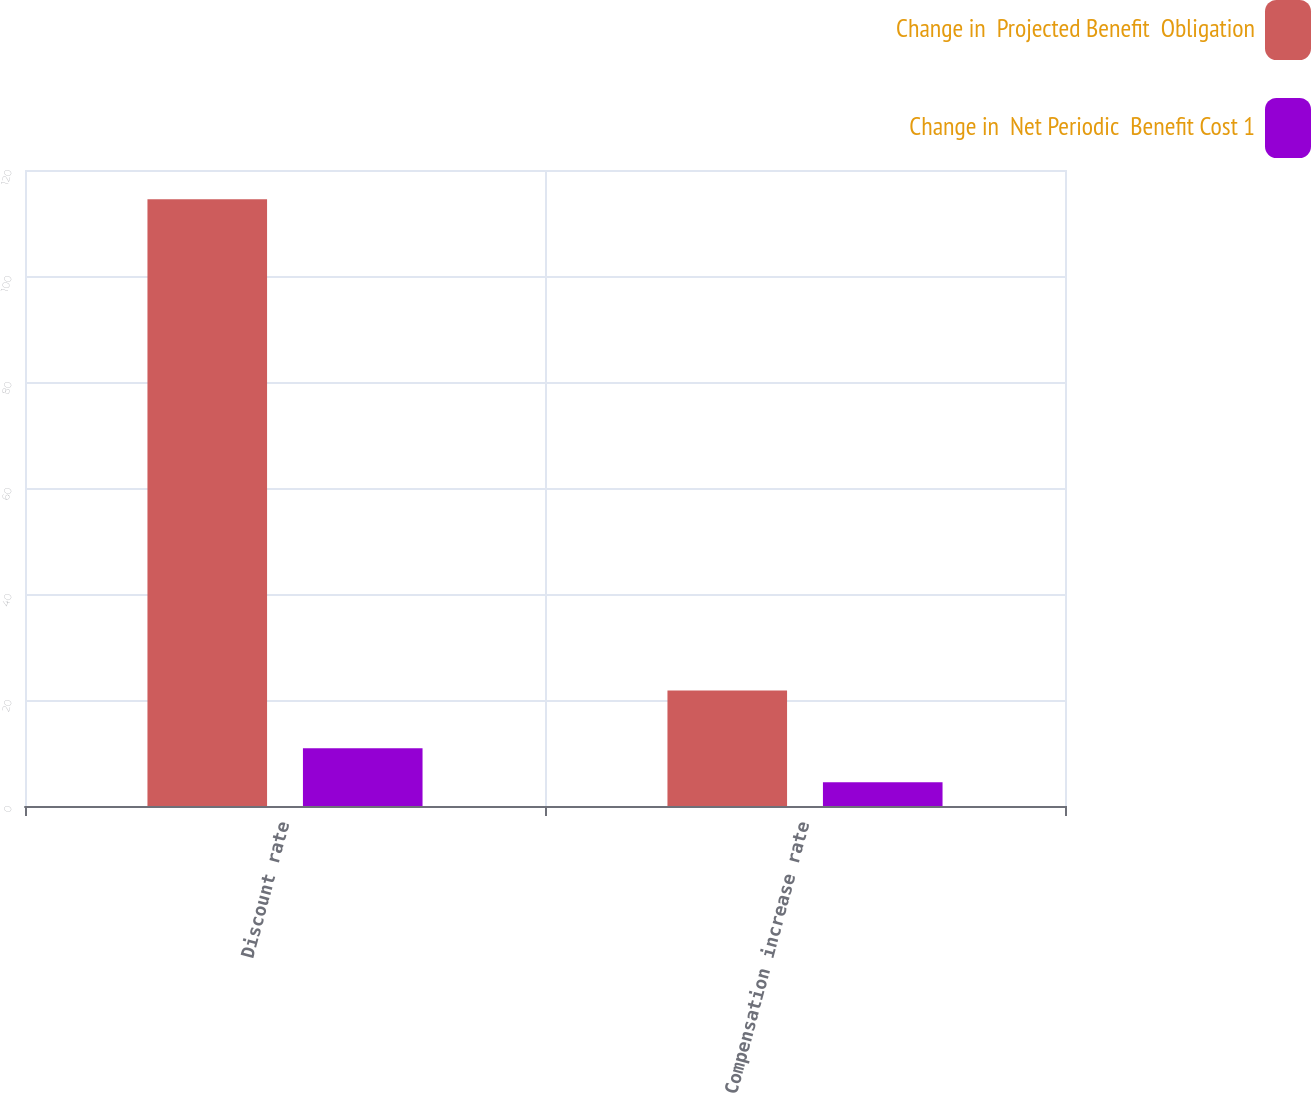Convert chart. <chart><loc_0><loc_0><loc_500><loc_500><stacked_bar_chart><ecel><fcel>Discount rate<fcel>Compensation increase rate<nl><fcel>Change in  Projected Benefit  Obligation<fcel>114.5<fcel>21.8<nl><fcel>Change in  Net Periodic  Benefit Cost 1<fcel>10.9<fcel>4.5<nl></chart> 